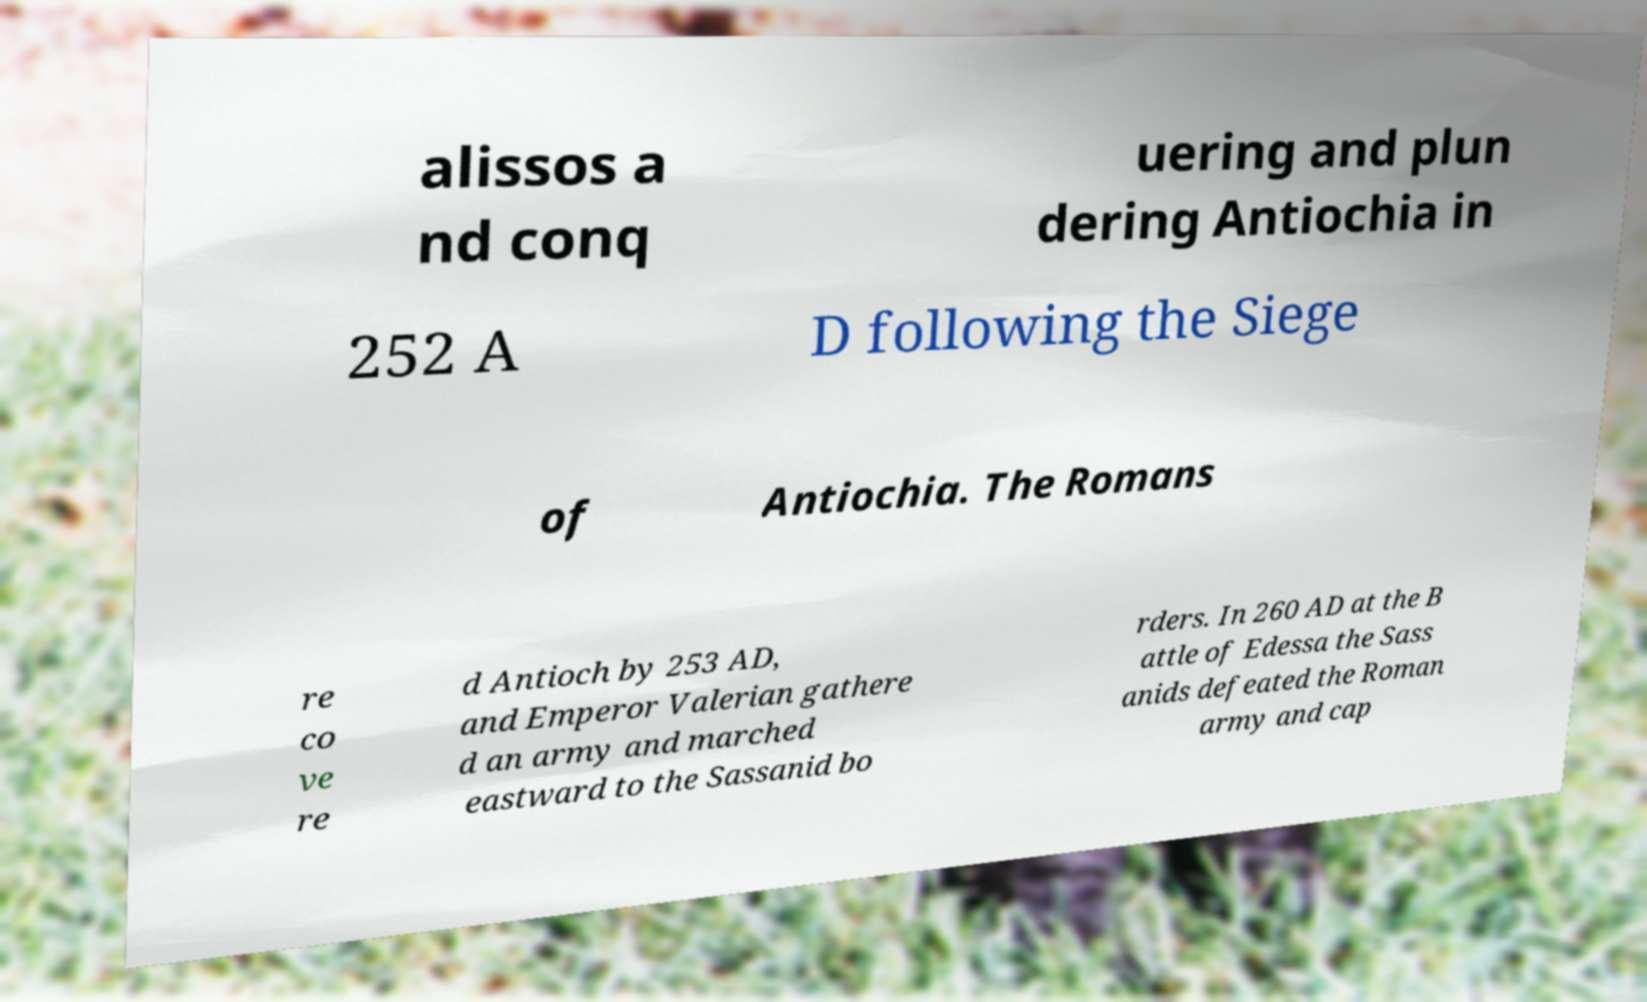What messages or text are displayed in this image? I need them in a readable, typed format. alissos a nd conq uering and plun dering Antiochia in 252 A D following the Siege of Antiochia. The Romans re co ve re d Antioch by 253 AD, and Emperor Valerian gathere d an army and marched eastward to the Sassanid bo rders. In 260 AD at the B attle of Edessa the Sass anids defeated the Roman army and cap 